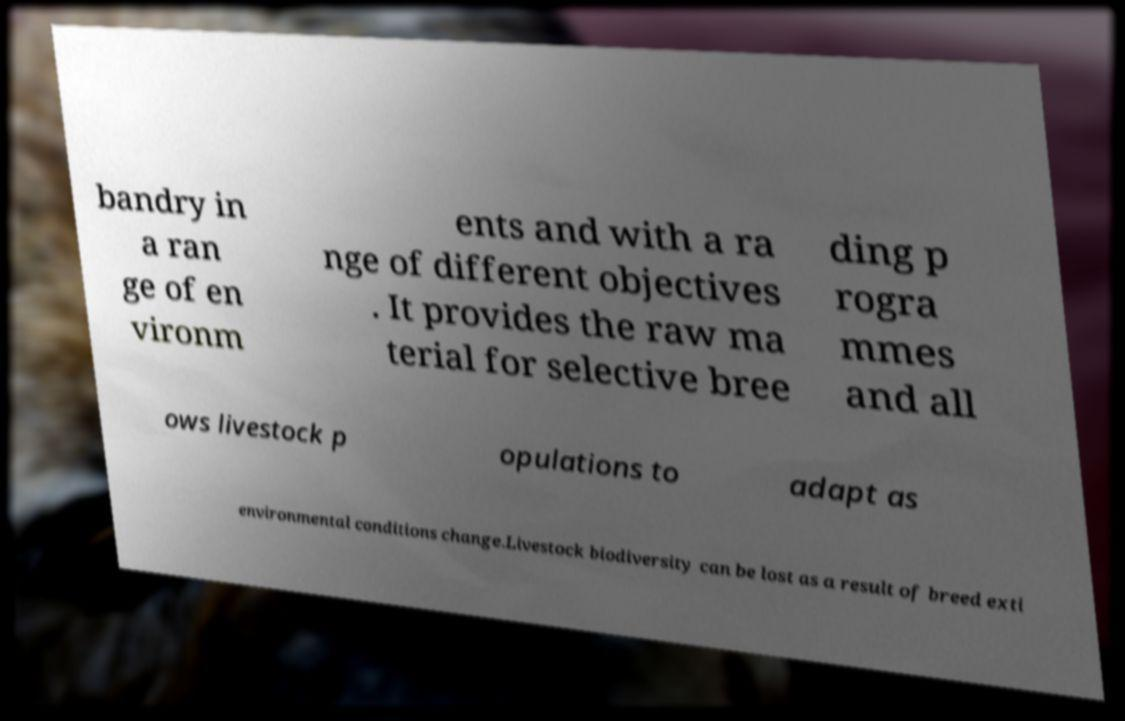Please read and relay the text visible in this image. What does it say? bandry in a ran ge of en vironm ents and with a ra nge of different objectives . It provides the raw ma terial for selective bree ding p rogra mmes and all ows livestock p opulations to adapt as environmental conditions change.Livestock biodiversity can be lost as a result of breed exti 